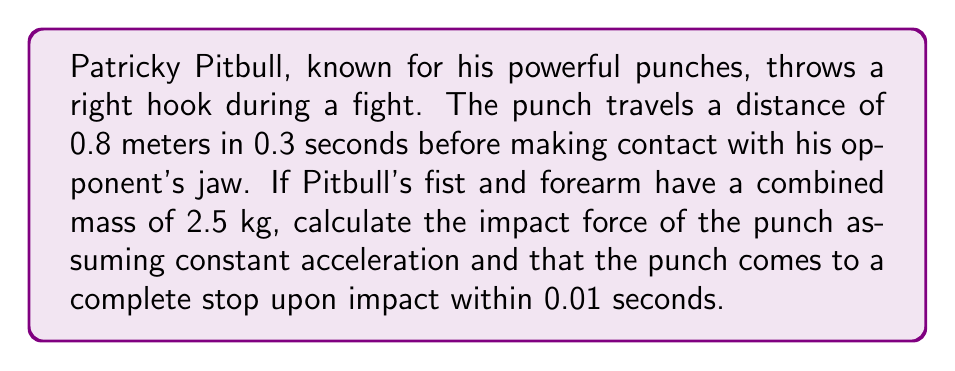Could you help me with this problem? To solve this problem, we'll use the principles of kinematics and Newton's Second Law. Let's break it down step by step:

1. Calculate the average velocity of the punch:
   $$v_{avg} = \frac{distance}{time} = \frac{0.8 \text{ m}}{0.3 \text{ s}} = 2.67 \text{ m/s}$$

2. Assuming constant acceleration, the final velocity just before impact is:
   $$v_{f} = 2 \times v_{avg} = 2 \times 2.67 = 5.34 \text{ m/s}$$

3. Calculate the deceleration during impact:
   $$a = \frac{v_f - 0}{t} = \frac{5.34 \text{ m/s} - 0}{0.01 \text{ s}} = 534 \text{ m/s}^2$$

4. Use Newton's Second Law to calculate the force:
   $$F = ma = 2.5 \text{ kg} \times 534 \text{ m/s}^2 = 1335 \text{ N}$$

Therefore, the impact force of Patricky Pitbull's punch is approximately 1335 N.
Answer: The impact force of Patricky Pitbull's punch is approximately 1335 N. 